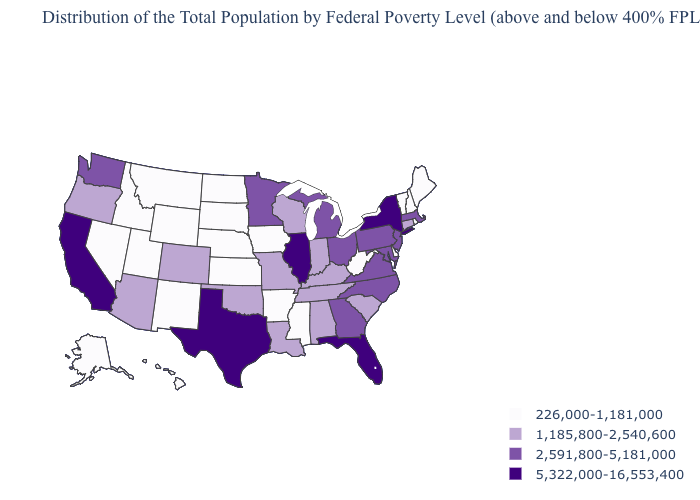Name the states that have a value in the range 2,591,800-5,181,000?
Give a very brief answer. Georgia, Maryland, Massachusetts, Michigan, Minnesota, New Jersey, North Carolina, Ohio, Pennsylvania, Virginia, Washington. What is the value of New Hampshire?
Concise answer only. 226,000-1,181,000. What is the value of South Dakota?
Write a very short answer. 226,000-1,181,000. What is the highest value in states that border North Carolina?
Answer briefly. 2,591,800-5,181,000. Among the states that border South Carolina , which have the highest value?
Keep it brief. Georgia, North Carolina. Does the map have missing data?
Keep it brief. No. Does Illinois have the highest value in the MidWest?
Be succinct. Yes. What is the value of Ohio?
Give a very brief answer. 2,591,800-5,181,000. What is the highest value in the USA?
Short answer required. 5,322,000-16,553,400. What is the value of Missouri?
Be succinct. 1,185,800-2,540,600. What is the value of South Carolina?
Short answer required. 1,185,800-2,540,600. How many symbols are there in the legend?
Concise answer only. 4. Which states have the highest value in the USA?
Give a very brief answer. California, Florida, Illinois, New York, Texas. What is the lowest value in states that border Maine?
Short answer required. 226,000-1,181,000. Does Minnesota have the highest value in the USA?
Quick response, please. No. 